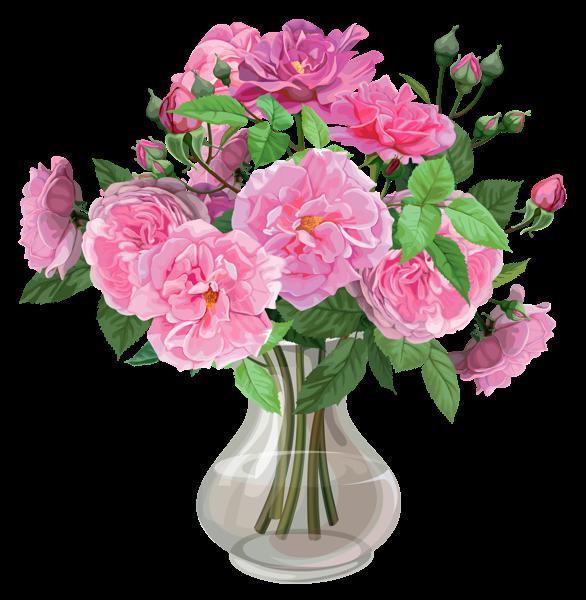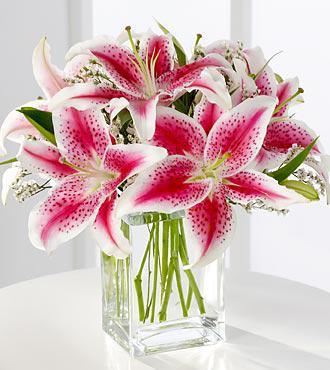The first image is the image on the left, the second image is the image on the right. Assess this claim about the two images: "There are at least five pink flowers with some green leaves set in a square vase to reveal the top of the flowers.". Correct or not? Answer yes or no. Yes. 